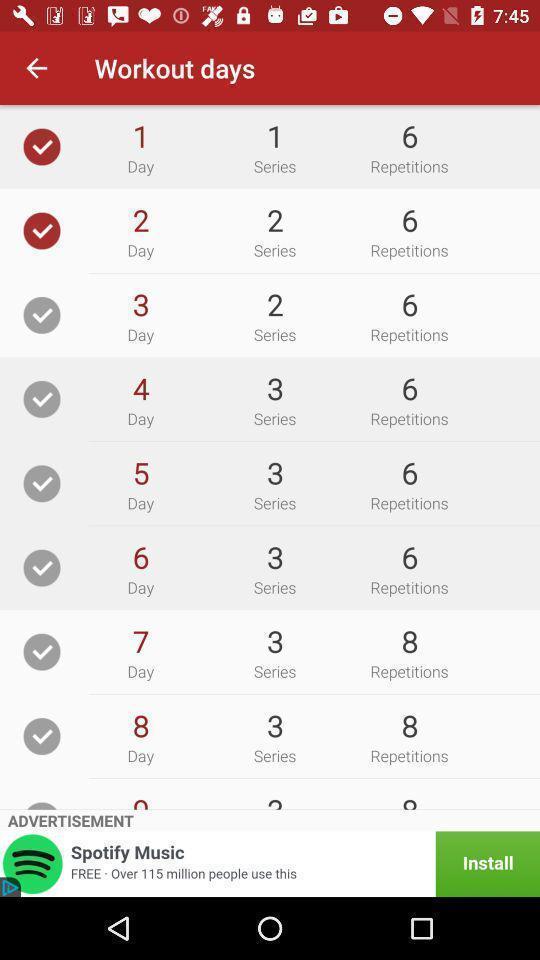Give me a summary of this screen capture. Work out schedule of an aerobics app. 